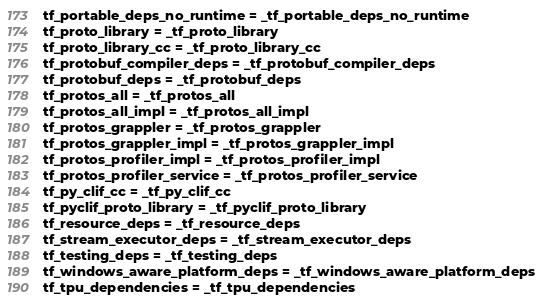<code> <loc_0><loc_0><loc_500><loc_500><_Python_>tf_portable_deps_no_runtime = _tf_portable_deps_no_runtime
tf_proto_library = _tf_proto_library
tf_proto_library_cc = _tf_proto_library_cc
tf_protobuf_compiler_deps = _tf_protobuf_compiler_deps
tf_protobuf_deps = _tf_protobuf_deps
tf_protos_all = _tf_protos_all
tf_protos_all_impl = _tf_protos_all_impl
tf_protos_grappler = _tf_protos_grappler
tf_protos_grappler_impl = _tf_protos_grappler_impl
tf_protos_profiler_impl = _tf_protos_profiler_impl
tf_protos_profiler_service = _tf_protos_profiler_service
tf_py_clif_cc = _tf_py_clif_cc
tf_pyclif_proto_library = _tf_pyclif_proto_library
tf_resource_deps = _tf_resource_deps
tf_stream_executor_deps = _tf_stream_executor_deps
tf_testing_deps = _tf_testing_deps
tf_windows_aware_platform_deps = _tf_windows_aware_platform_deps
tf_tpu_dependencies = _tf_tpu_dependencies
</code> 